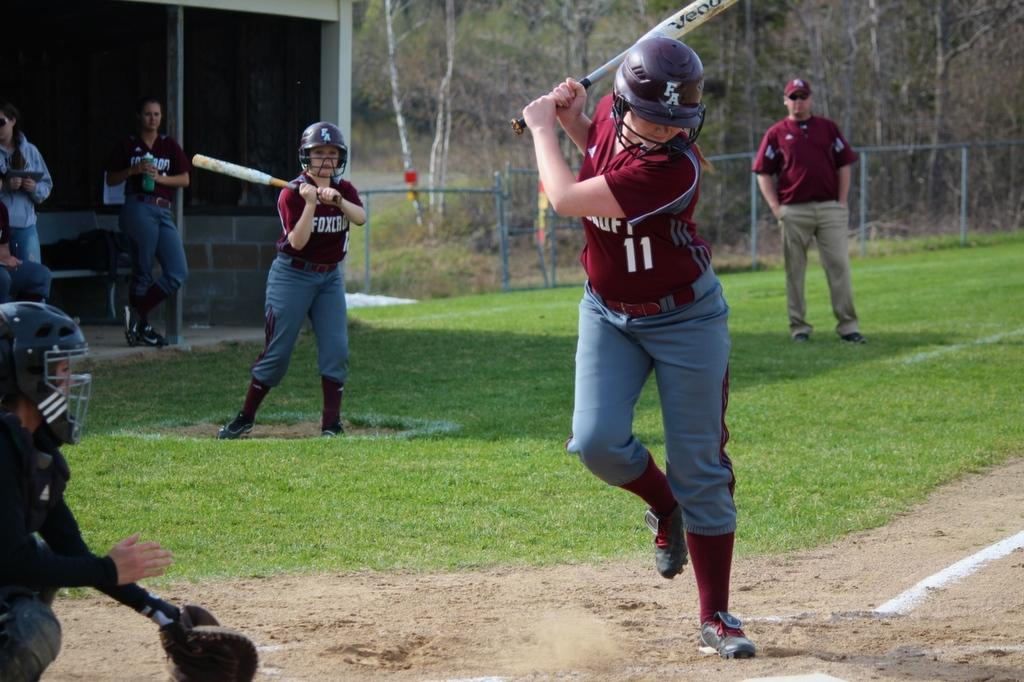<image>
Write a terse but informative summary of the picture. number 11 player of the red team is batting 